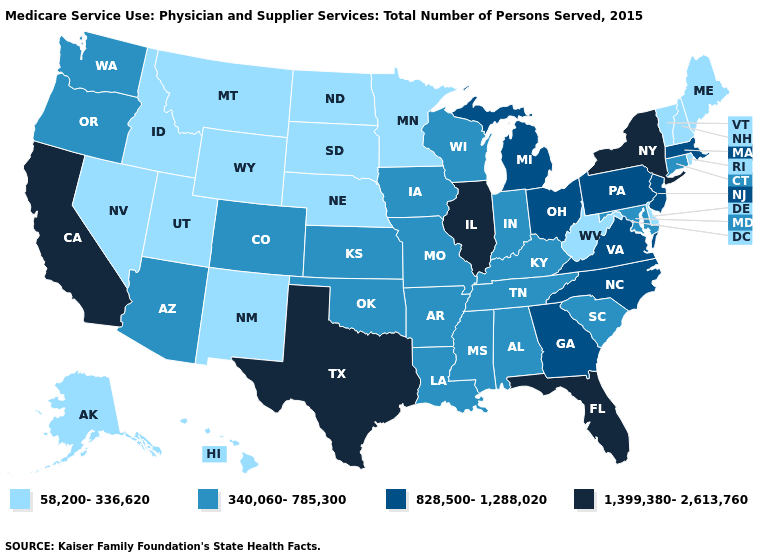Name the states that have a value in the range 828,500-1,288,020?
Short answer required. Georgia, Massachusetts, Michigan, New Jersey, North Carolina, Ohio, Pennsylvania, Virginia. What is the highest value in states that border Minnesota?
Short answer required. 340,060-785,300. What is the lowest value in the South?
Short answer required. 58,200-336,620. Name the states that have a value in the range 1,399,380-2,613,760?
Answer briefly. California, Florida, Illinois, New York, Texas. What is the value of Montana?
Be succinct. 58,200-336,620. Does Minnesota have the lowest value in the USA?
Short answer required. Yes. What is the highest value in the USA?
Write a very short answer. 1,399,380-2,613,760. What is the highest value in the USA?
Be succinct. 1,399,380-2,613,760. Which states have the lowest value in the USA?
Answer briefly. Alaska, Delaware, Hawaii, Idaho, Maine, Minnesota, Montana, Nebraska, Nevada, New Hampshire, New Mexico, North Dakota, Rhode Island, South Dakota, Utah, Vermont, West Virginia, Wyoming. What is the value of Illinois?
Short answer required. 1,399,380-2,613,760. Name the states that have a value in the range 1,399,380-2,613,760?
Write a very short answer. California, Florida, Illinois, New York, Texas. Does Rhode Island have the highest value in the USA?
Concise answer only. No. Does Maryland have a higher value than Nebraska?
Give a very brief answer. Yes. What is the value of North Carolina?
Answer briefly. 828,500-1,288,020. What is the value of Florida?
Answer briefly. 1,399,380-2,613,760. 